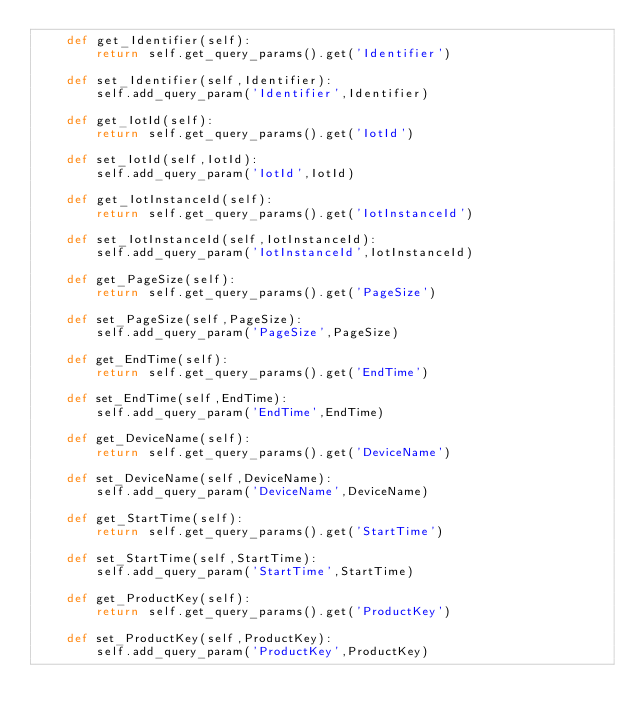Convert code to text. <code><loc_0><loc_0><loc_500><loc_500><_Python_>	def get_Identifier(self):
		return self.get_query_params().get('Identifier')

	def set_Identifier(self,Identifier):
		self.add_query_param('Identifier',Identifier)

	def get_IotId(self):
		return self.get_query_params().get('IotId')

	def set_IotId(self,IotId):
		self.add_query_param('IotId',IotId)

	def get_IotInstanceId(self):
		return self.get_query_params().get('IotInstanceId')

	def set_IotInstanceId(self,IotInstanceId):
		self.add_query_param('IotInstanceId',IotInstanceId)

	def get_PageSize(self):
		return self.get_query_params().get('PageSize')

	def set_PageSize(self,PageSize):
		self.add_query_param('PageSize',PageSize)

	def get_EndTime(self):
		return self.get_query_params().get('EndTime')

	def set_EndTime(self,EndTime):
		self.add_query_param('EndTime',EndTime)

	def get_DeviceName(self):
		return self.get_query_params().get('DeviceName')

	def set_DeviceName(self,DeviceName):
		self.add_query_param('DeviceName',DeviceName)

	def get_StartTime(self):
		return self.get_query_params().get('StartTime')

	def set_StartTime(self,StartTime):
		self.add_query_param('StartTime',StartTime)

	def get_ProductKey(self):
		return self.get_query_params().get('ProductKey')

	def set_ProductKey(self,ProductKey):
		self.add_query_param('ProductKey',ProductKey)</code> 